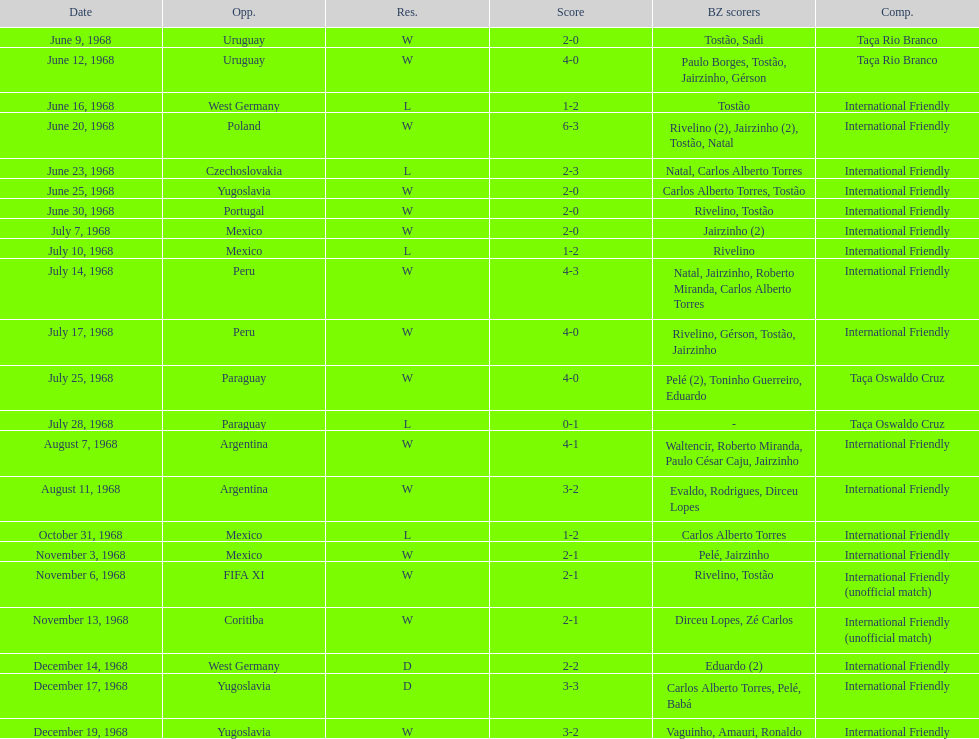How many matches are wins? 15. 